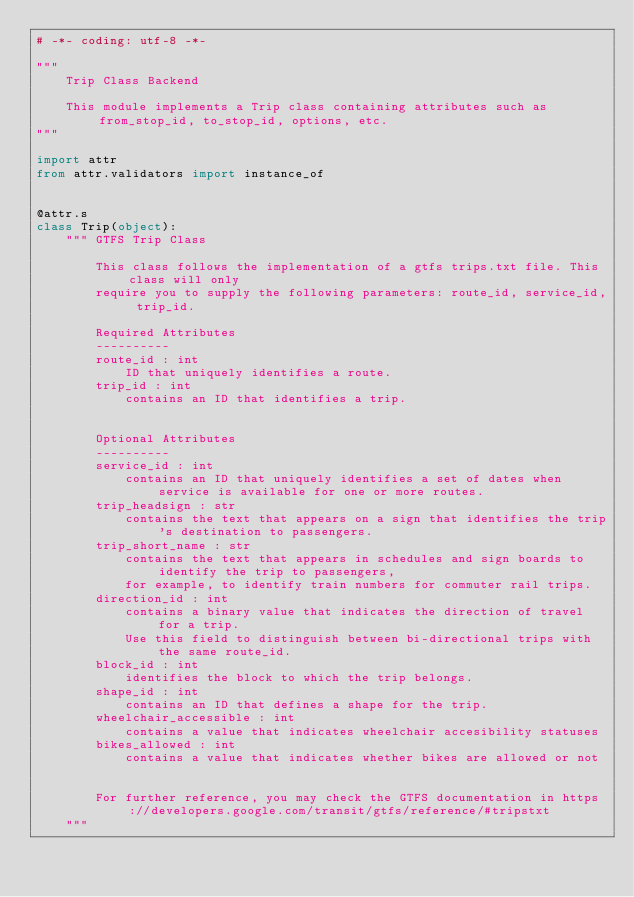<code> <loc_0><loc_0><loc_500><loc_500><_Python_># -*- coding: utf-8 -*-

"""
    Trip Class Backend

    This module implements a Trip class containing attributes such as from_stop_id, to_stop_id, options, etc.
"""

import attr
from attr.validators import instance_of


@attr.s
class Trip(object):
    """ GTFS Trip Class

        This class follows the implementation of a gtfs trips.txt file. This class will only 
        require you to supply the following parameters: route_id, service_id, trip_id.

        Required Attributes
        ----------
        route_id : int
            ID that uniquely identifies a route.
        trip_id : int
            contains an ID that identifies a trip.


        Optional Attributes
        ----------
        service_id : int
            contains an ID that uniquely identifies a set of dates when service is available for one or more routes. 
        trip_headsign : str
            contains the text that appears on a sign that identifies the trip's destination to passengers.
        trip_short_name : str
            contains the text that appears in schedules and sign boards to identify the trip to passengers,
            for example, to identify train numbers for commuter rail trips.
        direction_id : int
            contains a binary value that indicates the direction of travel for a trip.
            Use this field to distinguish between bi-directional trips with the same route_id.
        block_id : int
            identifies the block to which the trip belongs.
        shape_id : int
            contains an ID that defines a shape for the trip.
        wheelchair_accessible : int
            contains a value that indicates wheelchair accesibility statuses
        bikes_allowed : int
            contains a value that indicates whether bikes are allowed or not
        

        For further reference, you may check the GTFS documentation in https://developers.google.com/transit/gtfs/reference/#tripstxt
    """

</code> 